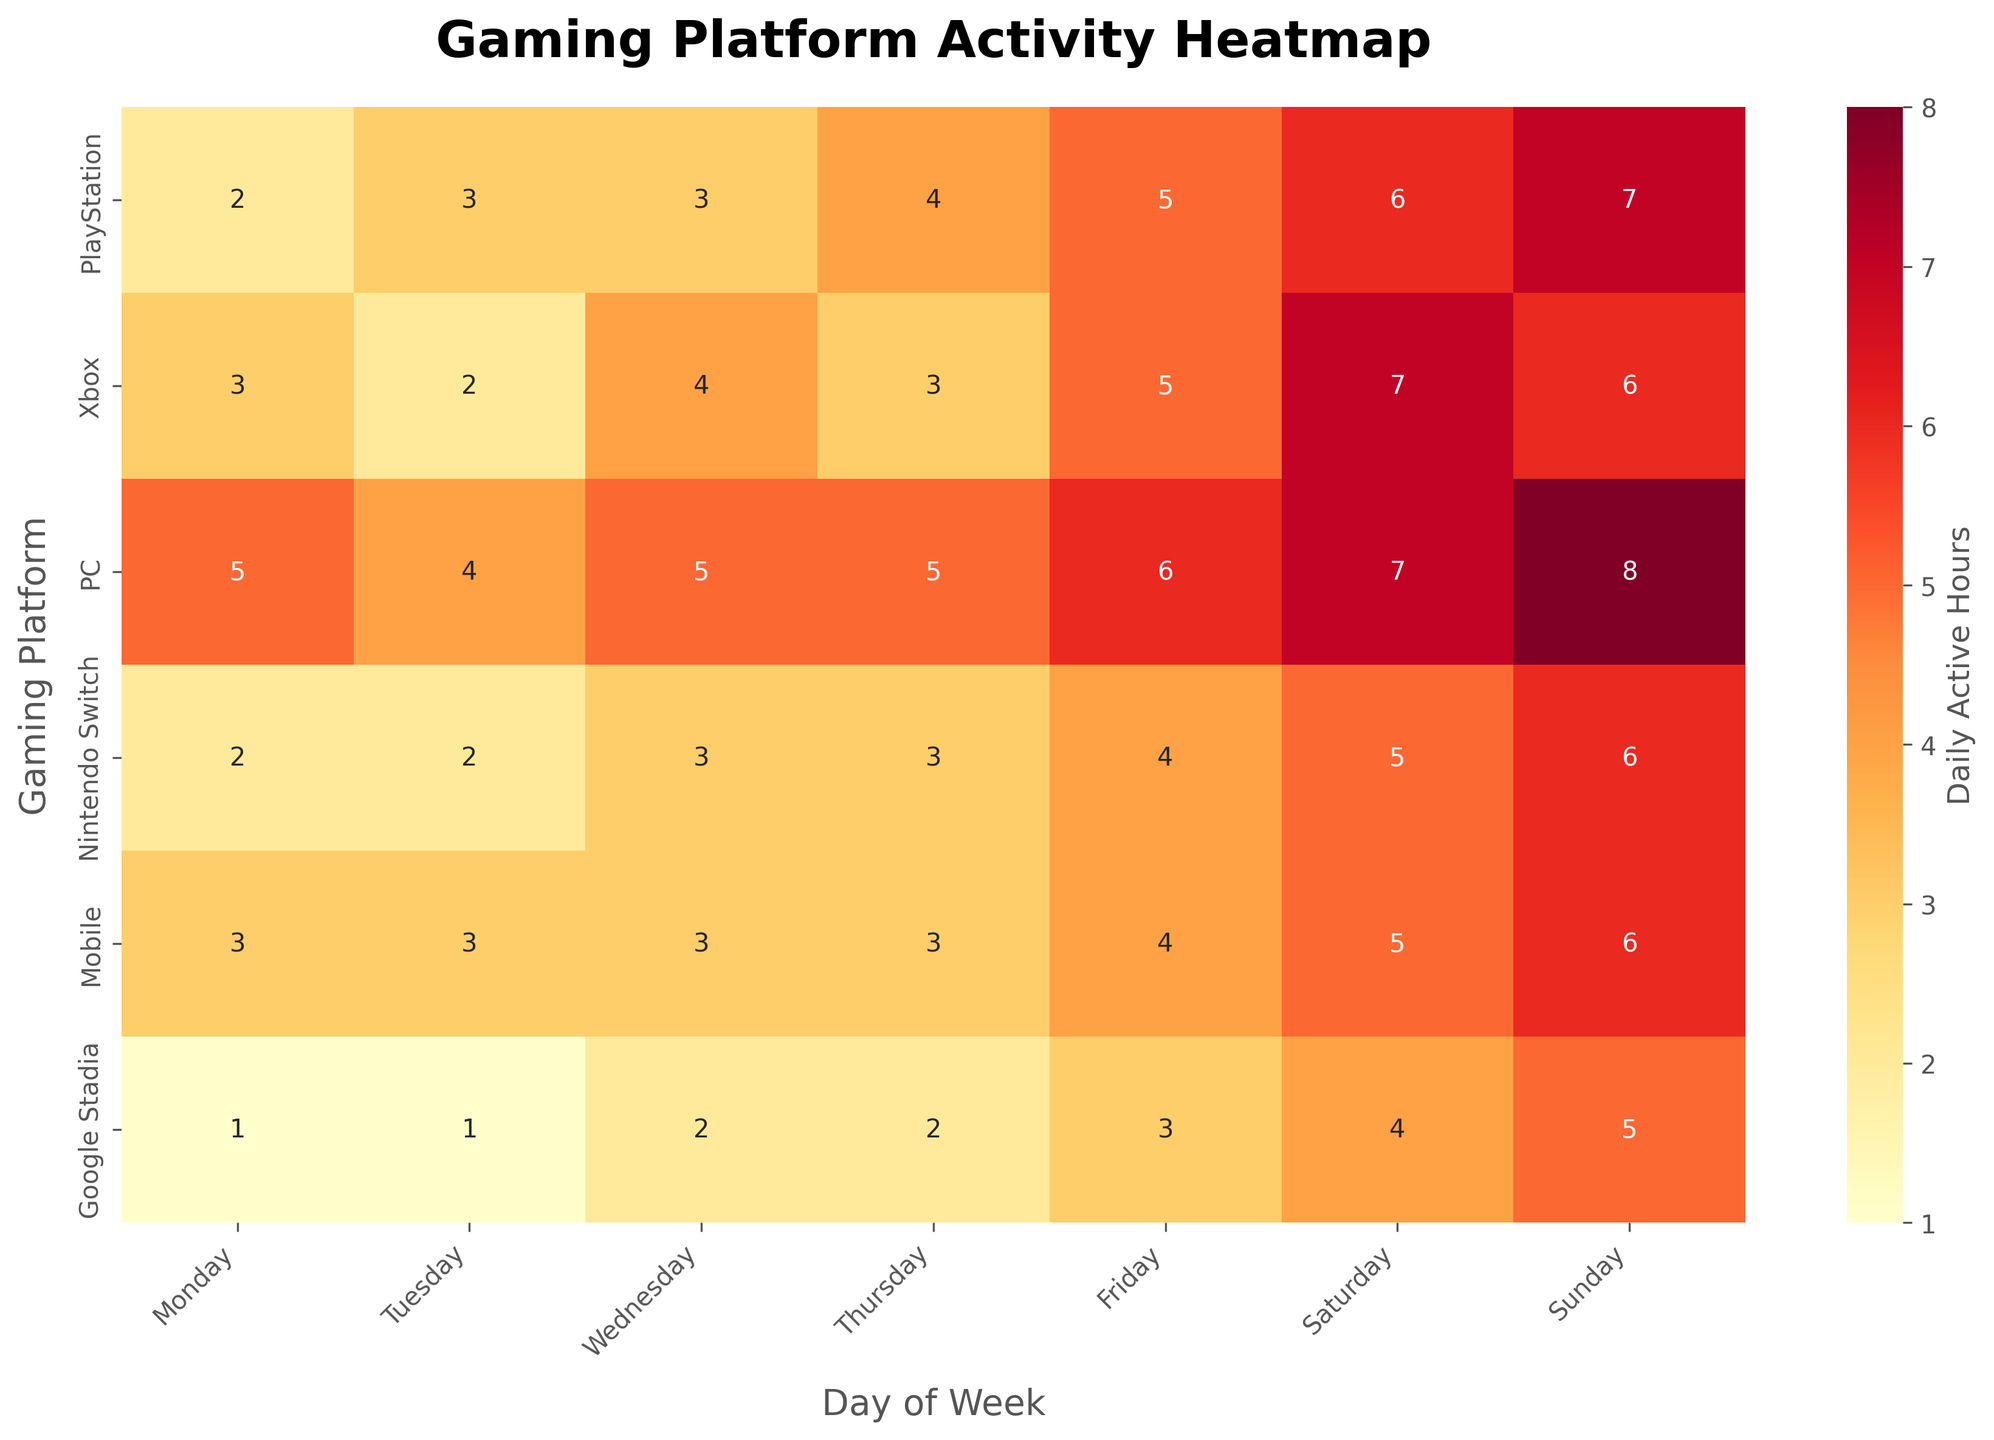What is the title of the heatmap? The title is positioned at the top of the heatmap and usually provides a summary of what the visual represents. By looking at the figure, we can easily read it.
Answer: Gaming Platform Activity Heatmap Which day has the highest activity on PlayStation? Scan the row corresponding to PlayStation and find the day with the highest value. For PlayStation, 7 is the highest, which occurs on Sunday.
Answer: Sunday How many active hours are there on average for Mobile on weekdays (Monday to Friday)? Add up the values for Mobile from Monday to Friday and divide by the number of days. The values are 3, 3, 3, 3, 4. Sum is 3+3+3+3+4=16 and the average is 16/5=3.2.
Answer: 3.2 Which platform has the least activity on Saturday? Compare the values for each platform in the Saturday column. Google Stadia has the least activity with 4 hours.
Answer: Google Stadia What is the difference in Sunday active hours between PC and Google Stadia? Subtract the active hours of Google Stadia on Sunday from those of PC (8 - 5 = 3).
Answer: 3 Which platform shows the most consistent activity across all days (least variation)? Calculate the range of active hours across all days for each platform and identify the smallest range. Google Stadia has a range from 1 to 5, which is the smallest.
Answer: Google Stadia What is the average daily activity for Xbox on weekends (Saturday and Sunday)? Add the values for Xbox on Saturday and Sunday, then divide by 2. The values are 7 and 6. Sum is 7+6=13 and the average is 13/2=6.5.
Answer: 6.5 On which day does PC have the most similar activity level to PlayStation? Compare the values on each day for PC and PlayStation to find the closest match. On Friday, both have 6.
Answer: Friday Which platform has the highest total activity over the whole week? Sum the daily active hours across all days for each platform and identify the highest. PC has the highest total activity with a sum of 40.
Answer: PC 